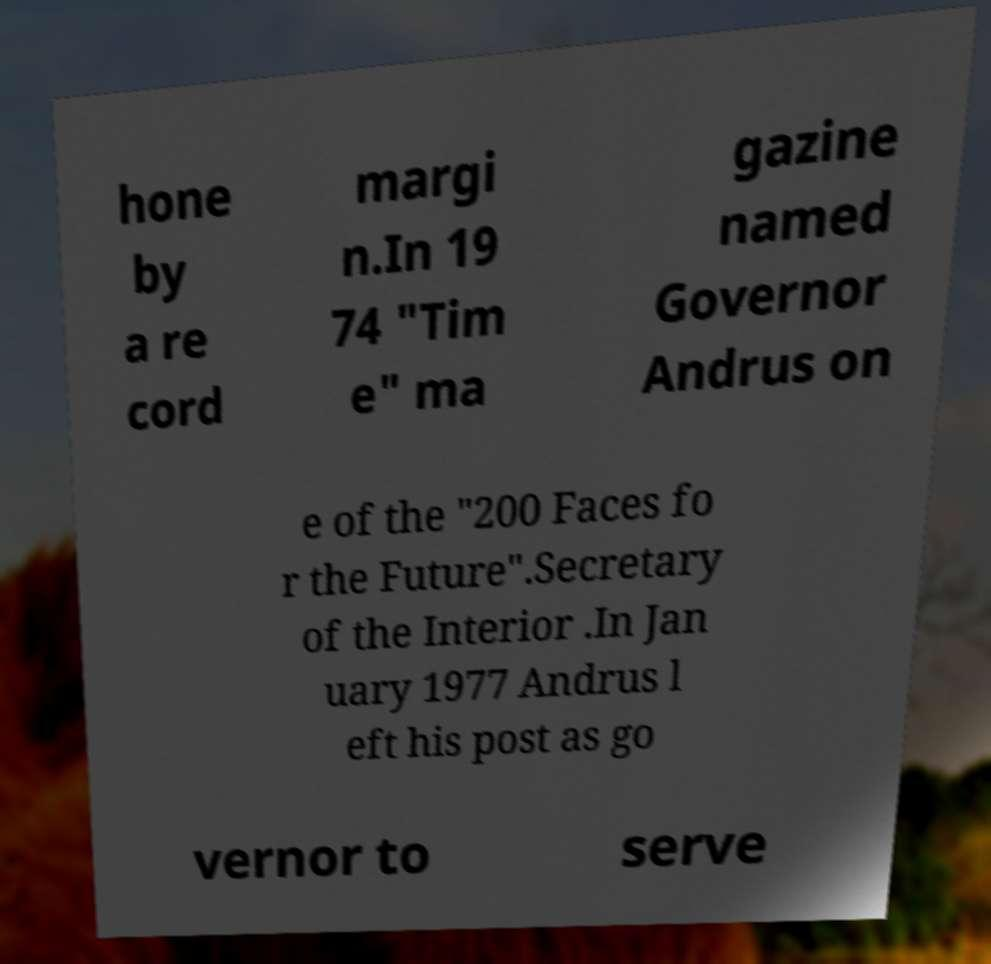There's text embedded in this image that I need extracted. Can you transcribe it verbatim? hone by a re cord margi n.In 19 74 "Tim e" ma gazine named Governor Andrus on e of the "200 Faces fo r the Future".Secretary of the Interior .In Jan uary 1977 Andrus l eft his post as go vernor to serve 